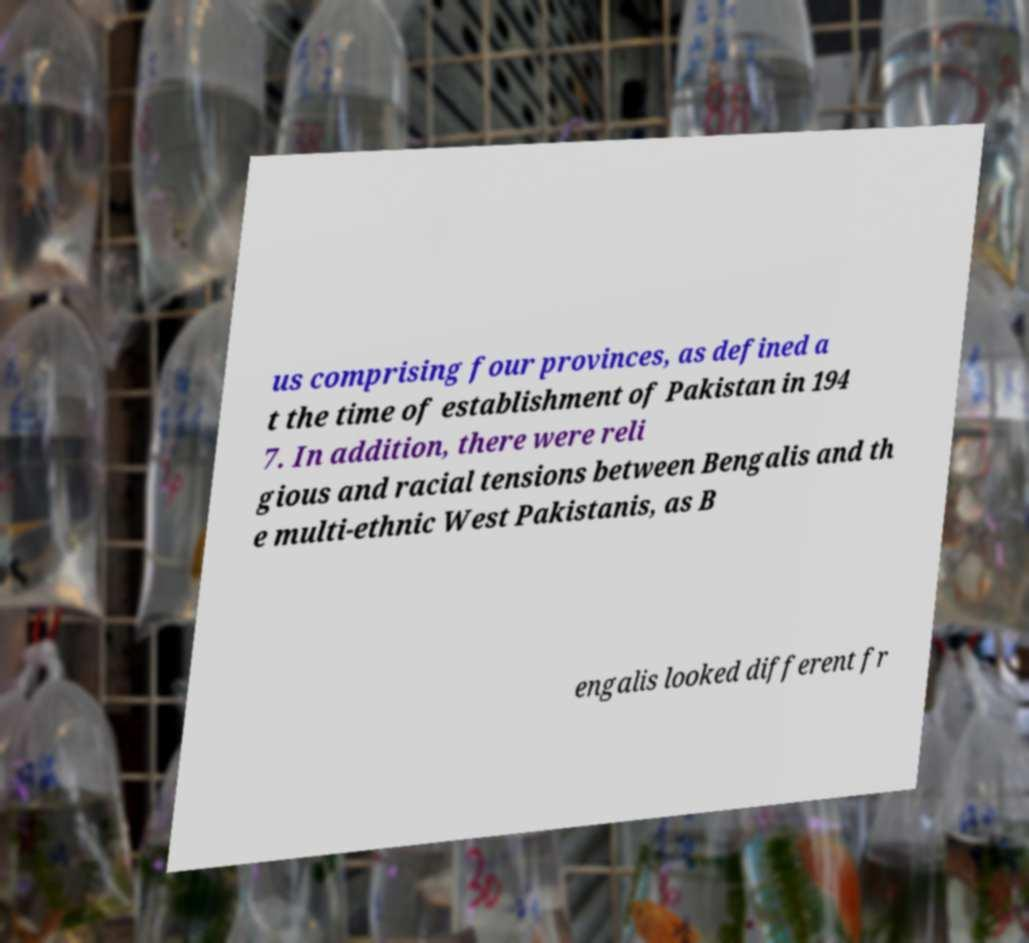What messages or text are displayed in this image? I need them in a readable, typed format. us comprising four provinces, as defined a t the time of establishment of Pakistan in 194 7. In addition, there were reli gious and racial tensions between Bengalis and th e multi-ethnic West Pakistanis, as B engalis looked different fr 